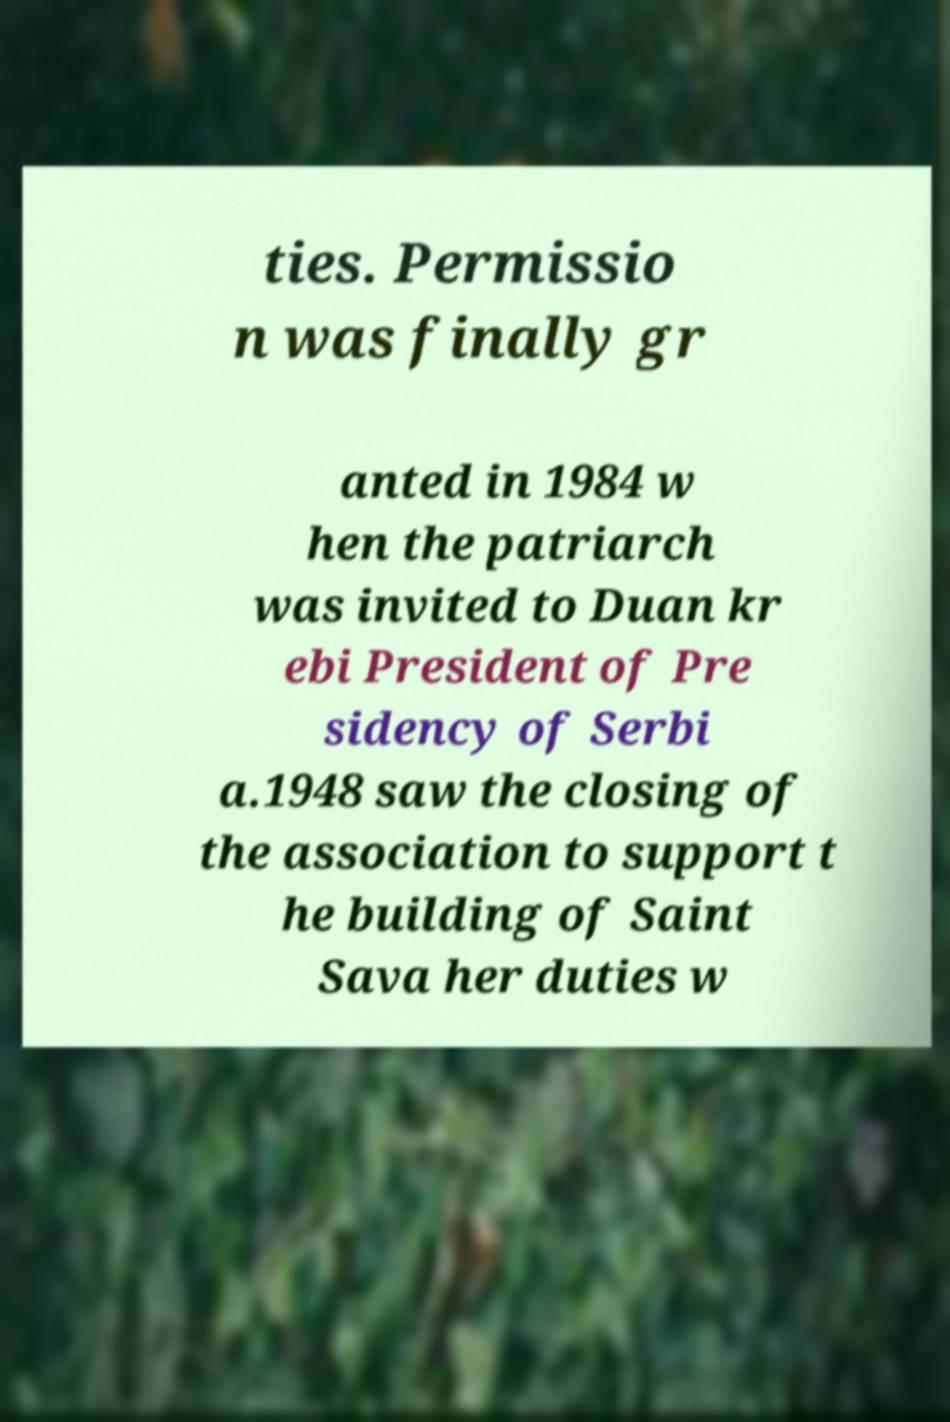What messages or text are displayed in this image? I need them in a readable, typed format. ties. Permissio n was finally gr anted in 1984 w hen the patriarch was invited to Duan kr ebi President of Pre sidency of Serbi a.1948 saw the closing of the association to support t he building of Saint Sava her duties w 